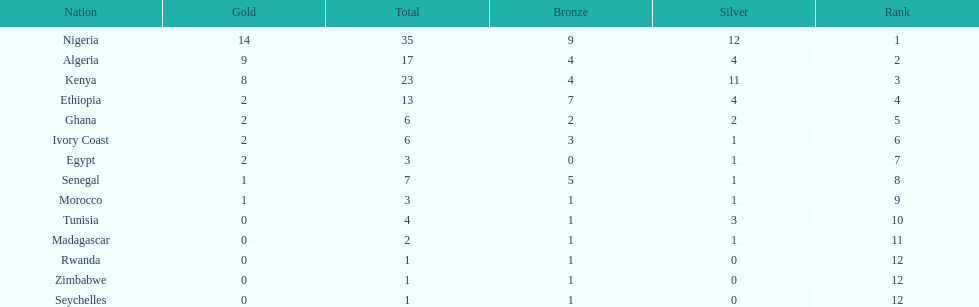What is the name of the first nation on this chart? Nigeria. 